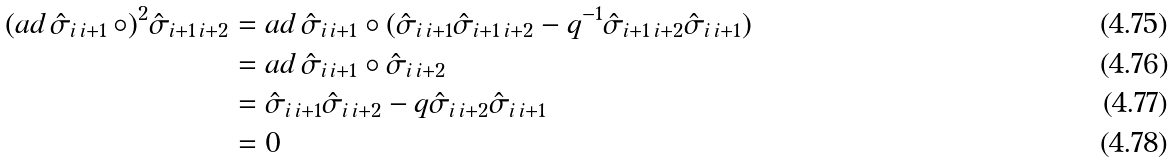<formula> <loc_0><loc_0><loc_500><loc_500>( a d \, \hat { \sigma } _ { i \, i + 1 } \, \circ ) ^ { 2 } \hat { \sigma } _ { i + 1 \, i + 2 } & = a d \, \hat { \sigma } _ { i \, i + 1 } \circ ( \hat { \sigma } _ { i \, i + 1 } \hat { \sigma } _ { i + 1 \, i + 2 } - q ^ { - 1 } \hat { \sigma } _ { i + 1 \, i + 2 } \hat { \sigma } _ { i \, i + 1 } ) \\ & = a d \, \hat { \sigma } _ { i \, i + 1 } \circ \hat { \sigma } _ { i \, i + 2 } \\ & = \hat { \sigma } _ { i \, i + 1 } \hat { \sigma } _ { i \, i + 2 } - q \hat { \sigma } _ { i \, i + 2 } \hat { \sigma } _ { i \, i + 1 } \\ & = 0</formula> 